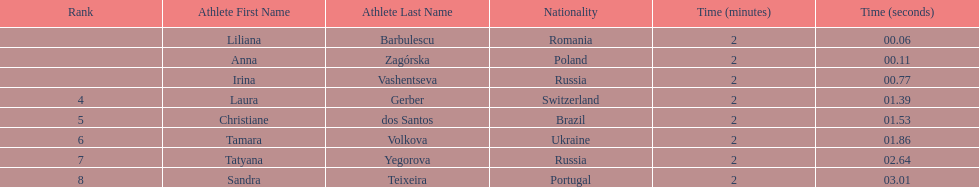Anna zagorska recieved 2nd place, what was her time? 2:00.11. 